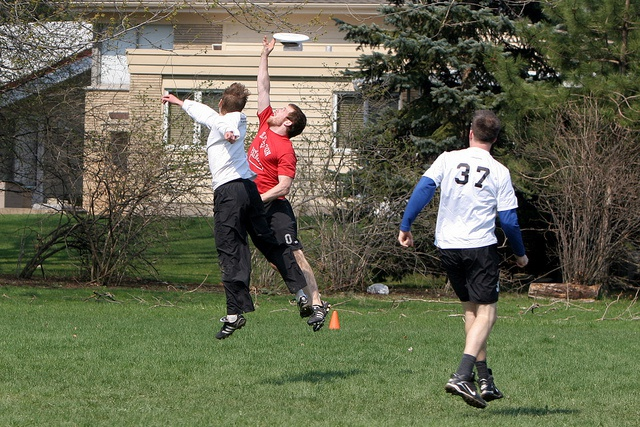Describe the objects in this image and their specific colors. I can see people in black, white, gray, and blue tones, people in black, white, gray, and darkgray tones, people in black, salmon, lightpink, and lightgray tones, and frisbee in black, white, darkgray, and gray tones in this image. 